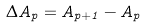<formula> <loc_0><loc_0><loc_500><loc_500>\Delta A _ { p } = A _ { p + 1 } - A _ { p }</formula> 